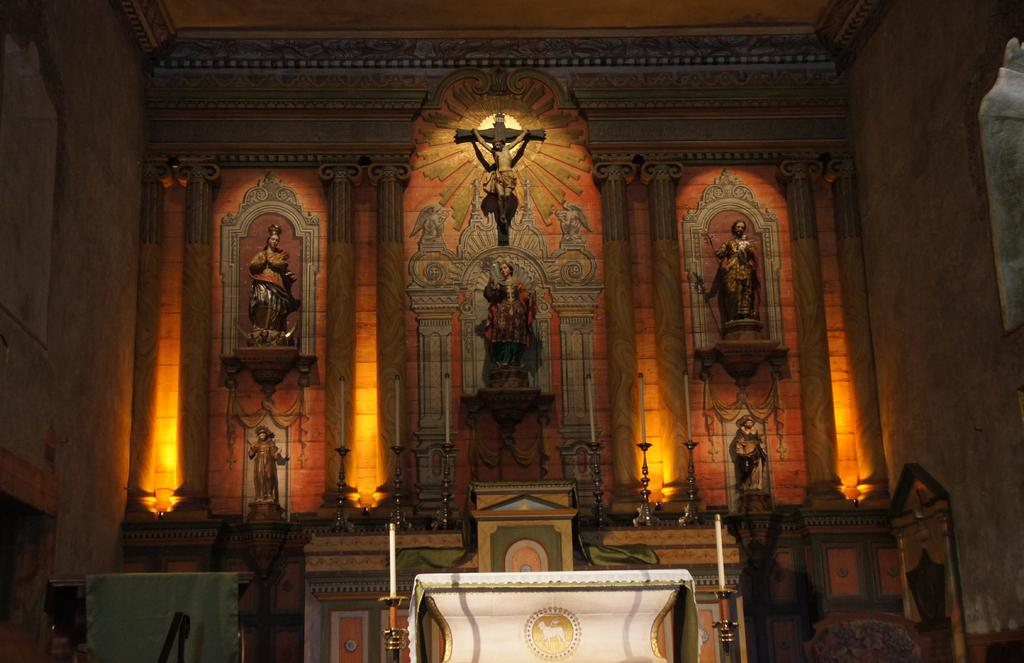What is the main piece of furniture in the image? There is a table in the image. What objects are placed on the table? There are candles on the table. What can be seen in the background of the image? There is a wall in the background of the image. What decorative item is on the wall? There is a sculpture on the wall. What type of nail is being used to hang the sculpture on the wall? There is no nail visible in the image, and the method of hanging the sculpture is not mentioned. 